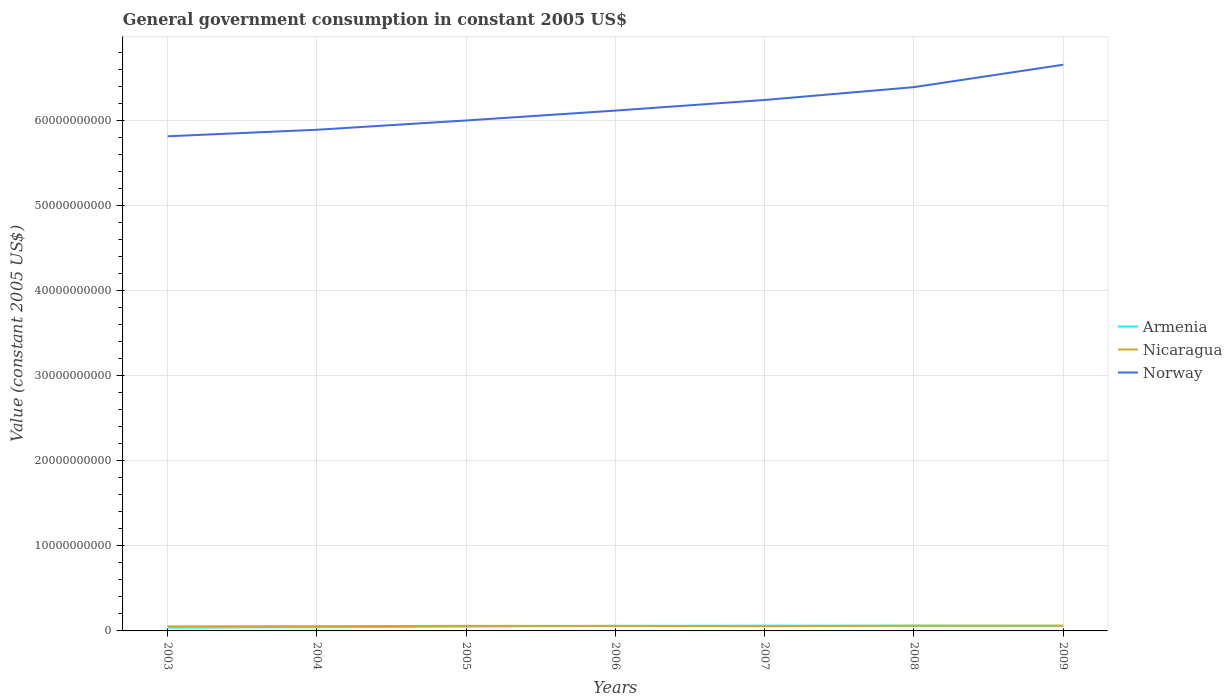How many different coloured lines are there?
Ensure brevity in your answer.  3. Does the line corresponding to Nicaragua intersect with the line corresponding to Armenia?
Provide a succinct answer. Yes. Is the number of lines equal to the number of legend labels?
Make the answer very short. Yes. Across all years, what is the maximum government conusmption in Armenia?
Offer a terse response. 3.91e+08. In which year was the government conusmption in Armenia maximum?
Provide a succinct answer. 2003. What is the total government conusmption in Nicaragua in the graph?
Ensure brevity in your answer.  -6.01e+07. What is the difference between the highest and the second highest government conusmption in Armenia?
Your response must be concise. 2.29e+08. What is the difference between the highest and the lowest government conusmption in Nicaragua?
Provide a short and direct response. 4. Are the values on the major ticks of Y-axis written in scientific E-notation?
Your answer should be very brief. No. Does the graph contain any zero values?
Keep it short and to the point. No. How many legend labels are there?
Offer a terse response. 3. What is the title of the graph?
Your answer should be compact. General government consumption in constant 2005 US$. Does "Bangladesh" appear as one of the legend labels in the graph?
Offer a very short reply. No. What is the label or title of the X-axis?
Provide a short and direct response. Years. What is the label or title of the Y-axis?
Your answer should be very brief. Value (constant 2005 US$). What is the Value (constant 2005 US$) in Armenia in 2003?
Offer a terse response. 3.91e+08. What is the Value (constant 2005 US$) in Nicaragua in 2003?
Give a very brief answer. 5.41e+08. What is the Value (constant 2005 US$) in Norway in 2003?
Provide a succinct answer. 5.82e+1. What is the Value (constant 2005 US$) in Armenia in 2004?
Your answer should be very brief. 4.34e+08. What is the Value (constant 2005 US$) of Nicaragua in 2004?
Give a very brief answer. 5.58e+08. What is the Value (constant 2005 US$) in Norway in 2004?
Provide a succinct answer. 5.89e+1. What is the Value (constant 2005 US$) in Armenia in 2005?
Ensure brevity in your answer.  5.17e+08. What is the Value (constant 2005 US$) in Nicaragua in 2005?
Ensure brevity in your answer.  5.96e+08. What is the Value (constant 2005 US$) in Norway in 2005?
Offer a terse response. 6.00e+1. What is the Value (constant 2005 US$) of Armenia in 2006?
Keep it short and to the point. 5.90e+08. What is the Value (constant 2005 US$) of Nicaragua in 2006?
Provide a succinct answer. 5.93e+08. What is the Value (constant 2005 US$) in Norway in 2006?
Provide a succinct answer. 6.12e+1. What is the Value (constant 2005 US$) in Armenia in 2007?
Provide a short and direct response. 6.20e+08. What is the Value (constant 2005 US$) in Nicaragua in 2007?
Your answer should be compact. 5.58e+08. What is the Value (constant 2005 US$) in Norway in 2007?
Your response must be concise. 6.24e+1. What is the Value (constant 2005 US$) of Armenia in 2008?
Your response must be concise. 6.09e+08. What is the Value (constant 2005 US$) of Nicaragua in 2008?
Give a very brief answer. 6.18e+08. What is the Value (constant 2005 US$) of Norway in 2008?
Ensure brevity in your answer.  6.39e+1. What is the Value (constant 2005 US$) of Armenia in 2009?
Your response must be concise. 6.01e+08. What is the Value (constant 2005 US$) in Nicaragua in 2009?
Give a very brief answer. 6.16e+08. What is the Value (constant 2005 US$) in Norway in 2009?
Your response must be concise. 6.66e+1. Across all years, what is the maximum Value (constant 2005 US$) in Armenia?
Make the answer very short. 6.20e+08. Across all years, what is the maximum Value (constant 2005 US$) of Nicaragua?
Provide a succinct answer. 6.18e+08. Across all years, what is the maximum Value (constant 2005 US$) of Norway?
Provide a succinct answer. 6.66e+1. Across all years, what is the minimum Value (constant 2005 US$) of Armenia?
Make the answer very short. 3.91e+08. Across all years, what is the minimum Value (constant 2005 US$) in Nicaragua?
Give a very brief answer. 5.41e+08. Across all years, what is the minimum Value (constant 2005 US$) in Norway?
Provide a succinct answer. 5.82e+1. What is the total Value (constant 2005 US$) in Armenia in the graph?
Ensure brevity in your answer.  3.76e+09. What is the total Value (constant 2005 US$) of Nicaragua in the graph?
Provide a short and direct response. 4.08e+09. What is the total Value (constant 2005 US$) in Norway in the graph?
Your answer should be very brief. 4.31e+11. What is the difference between the Value (constant 2005 US$) in Armenia in 2003 and that in 2004?
Make the answer very short. -4.30e+07. What is the difference between the Value (constant 2005 US$) in Nicaragua in 2003 and that in 2004?
Your answer should be compact. -1.71e+07. What is the difference between the Value (constant 2005 US$) of Norway in 2003 and that in 2004?
Keep it short and to the point. -7.66e+08. What is the difference between the Value (constant 2005 US$) of Armenia in 2003 and that in 2005?
Offer a terse response. -1.26e+08. What is the difference between the Value (constant 2005 US$) in Nicaragua in 2003 and that in 2005?
Ensure brevity in your answer.  -5.54e+07. What is the difference between the Value (constant 2005 US$) of Norway in 2003 and that in 2005?
Your answer should be compact. -1.86e+09. What is the difference between the Value (constant 2005 US$) of Armenia in 2003 and that in 2006?
Provide a short and direct response. -1.98e+08. What is the difference between the Value (constant 2005 US$) in Nicaragua in 2003 and that in 2006?
Provide a short and direct response. -5.22e+07. What is the difference between the Value (constant 2005 US$) of Norway in 2003 and that in 2006?
Your answer should be compact. -3.02e+09. What is the difference between the Value (constant 2005 US$) in Armenia in 2003 and that in 2007?
Offer a very short reply. -2.29e+08. What is the difference between the Value (constant 2005 US$) in Nicaragua in 2003 and that in 2007?
Your response must be concise. -1.73e+07. What is the difference between the Value (constant 2005 US$) of Norway in 2003 and that in 2007?
Your answer should be very brief. -4.27e+09. What is the difference between the Value (constant 2005 US$) in Armenia in 2003 and that in 2008?
Ensure brevity in your answer.  -2.17e+08. What is the difference between the Value (constant 2005 US$) in Nicaragua in 2003 and that in 2008?
Provide a succinct answer. -7.74e+07. What is the difference between the Value (constant 2005 US$) of Norway in 2003 and that in 2008?
Offer a very short reply. -5.78e+09. What is the difference between the Value (constant 2005 US$) in Armenia in 2003 and that in 2009?
Provide a short and direct response. -2.10e+08. What is the difference between the Value (constant 2005 US$) of Nicaragua in 2003 and that in 2009?
Make the answer very short. -7.58e+07. What is the difference between the Value (constant 2005 US$) of Norway in 2003 and that in 2009?
Give a very brief answer. -8.41e+09. What is the difference between the Value (constant 2005 US$) in Armenia in 2004 and that in 2005?
Give a very brief answer. -8.27e+07. What is the difference between the Value (constant 2005 US$) in Nicaragua in 2004 and that in 2005?
Provide a short and direct response. -3.83e+07. What is the difference between the Value (constant 2005 US$) of Norway in 2004 and that in 2005?
Offer a very short reply. -1.09e+09. What is the difference between the Value (constant 2005 US$) in Armenia in 2004 and that in 2006?
Your response must be concise. -1.55e+08. What is the difference between the Value (constant 2005 US$) of Nicaragua in 2004 and that in 2006?
Your answer should be very brief. -3.51e+07. What is the difference between the Value (constant 2005 US$) in Norway in 2004 and that in 2006?
Offer a very short reply. -2.25e+09. What is the difference between the Value (constant 2005 US$) in Armenia in 2004 and that in 2007?
Provide a short and direct response. -1.86e+08. What is the difference between the Value (constant 2005 US$) of Nicaragua in 2004 and that in 2007?
Your answer should be compact. -2.22e+05. What is the difference between the Value (constant 2005 US$) of Norway in 2004 and that in 2007?
Provide a succinct answer. -3.50e+09. What is the difference between the Value (constant 2005 US$) of Armenia in 2004 and that in 2008?
Make the answer very short. -1.74e+08. What is the difference between the Value (constant 2005 US$) in Nicaragua in 2004 and that in 2008?
Keep it short and to the point. -6.03e+07. What is the difference between the Value (constant 2005 US$) of Norway in 2004 and that in 2008?
Give a very brief answer. -5.01e+09. What is the difference between the Value (constant 2005 US$) of Armenia in 2004 and that in 2009?
Your response must be concise. -1.67e+08. What is the difference between the Value (constant 2005 US$) of Nicaragua in 2004 and that in 2009?
Keep it short and to the point. -5.87e+07. What is the difference between the Value (constant 2005 US$) of Norway in 2004 and that in 2009?
Give a very brief answer. -7.65e+09. What is the difference between the Value (constant 2005 US$) in Armenia in 2005 and that in 2006?
Ensure brevity in your answer.  -7.25e+07. What is the difference between the Value (constant 2005 US$) in Nicaragua in 2005 and that in 2006?
Give a very brief answer. 3.12e+06. What is the difference between the Value (constant 2005 US$) of Norway in 2005 and that in 2006?
Make the answer very short. -1.16e+09. What is the difference between the Value (constant 2005 US$) in Armenia in 2005 and that in 2007?
Make the answer very short. -1.03e+08. What is the difference between the Value (constant 2005 US$) in Nicaragua in 2005 and that in 2007?
Ensure brevity in your answer.  3.80e+07. What is the difference between the Value (constant 2005 US$) in Norway in 2005 and that in 2007?
Provide a short and direct response. -2.41e+09. What is the difference between the Value (constant 2005 US$) in Armenia in 2005 and that in 2008?
Your response must be concise. -9.18e+07. What is the difference between the Value (constant 2005 US$) of Nicaragua in 2005 and that in 2008?
Your answer should be very brief. -2.21e+07. What is the difference between the Value (constant 2005 US$) in Norway in 2005 and that in 2008?
Your answer should be very brief. -3.92e+09. What is the difference between the Value (constant 2005 US$) of Armenia in 2005 and that in 2009?
Your answer should be compact. -8.43e+07. What is the difference between the Value (constant 2005 US$) in Nicaragua in 2005 and that in 2009?
Offer a terse response. -2.04e+07. What is the difference between the Value (constant 2005 US$) of Norway in 2005 and that in 2009?
Provide a succinct answer. -6.56e+09. What is the difference between the Value (constant 2005 US$) of Armenia in 2006 and that in 2007?
Give a very brief answer. -3.08e+07. What is the difference between the Value (constant 2005 US$) in Nicaragua in 2006 and that in 2007?
Keep it short and to the point. 3.49e+07. What is the difference between the Value (constant 2005 US$) in Norway in 2006 and that in 2007?
Make the answer very short. -1.25e+09. What is the difference between the Value (constant 2005 US$) in Armenia in 2006 and that in 2008?
Offer a very short reply. -1.92e+07. What is the difference between the Value (constant 2005 US$) in Nicaragua in 2006 and that in 2008?
Your response must be concise. -2.52e+07. What is the difference between the Value (constant 2005 US$) of Norway in 2006 and that in 2008?
Give a very brief answer. -2.76e+09. What is the difference between the Value (constant 2005 US$) of Armenia in 2006 and that in 2009?
Ensure brevity in your answer.  -1.18e+07. What is the difference between the Value (constant 2005 US$) in Nicaragua in 2006 and that in 2009?
Make the answer very short. -2.36e+07. What is the difference between the Value (constant 2005 US$) in Norway in 2006 and that in 2009?
Offer a terse response. -5.39e+09. What is the difference between the Value (constant 2005 US$) in Armenia in 2007 and that in 2008?
Give a very brief answer. 1.15e+07. What is the difference between the Value (constant 2005 US$) in Nicaragua in 2007 and that in 2008?
Provide a succinct answer. -6.01e+07. What is the difference between the Value (constant 2005 US$) in Norway in 2007 and that in 2008?
Your answer should be compact. -1.51e+09. What is the difference between the Value (constant 2005 US$) in Armenia in 2007 and that in 2009?
Offer a very short reply. 1.90e+07. What is the difference between the Value (constant 2005 US$) of Nicaragua in 2007 and that in 2009?
Offer a very short reply. -5.85e+07. What is the difference between the Value (constant 2005 US$) in Norway in 2007 and that in 2009?
Your response must be concise. -4.15e+09. What is the difference between the Value (constant 2005 US$) in Armenia in 2008 and that in 2009?
Your answer should be compact. 7.45e+06. What is the difference between the Value (constant 2005 US$) in Nicaragua in 2008 and that in 2009?
Your answer should be very brief. 1.63e+06. What is the difference between the Value (constant 2005 US$) in Norway in 2008 and that in 2009?
Provide a short and direct response. -2.64e+09. What is the difference between the Value (constant 2005 US$) in Armenia in 2003 and the Value (constant 2005 US$) in Nicaragua in 2004?
Offer a very short reply. -1.66e+08. What is the difference between the Value (constant 2005 US$) in Armenia in 2003 and the Value (constant 2005 US$) in Norway in 2004?
Offer a very short reply. -5.85e+1. What is the difference between the Value (constant 2005 US$) in Nicaragua in 2003 and the Value (constant 2005 US$) in Norway in 2004?
Your answer should be very brief. -5.84e+1. What is the difference between the Value (constant 2005 US$) in Armenia in 2003 and the Value (constant 2005 US$) in Nicaragua in 2005?
Provide a succinct answer. -2.05e+08. What is the difference between the Value (constant 2005 US$) of Armenia in 2003 and the Value (constant 2005 US$) of Norway in 2005?
Your answer should be compact. -5.96e+1. What is the difference between the Value (constant 2005 US$) of Nicaragua in 2003 and the Value (constant 2005 US$) of Norway in 2005?
Your answer should be very brief. -5.95e+1. What is the difference between the Value (constant 2005 US$) of Armenia in 2003 and the Value (constant 2005 US$) of Nicaragua in 2006?
Provide a succinct answer. -2.02e+08. What is the difference between the Value (constant 2005 US$) of Armenia in 2003 and the Value (constant 2005 US$) of Norway in 2006?
Your response must be concise. -6.08e+1. What is the difference between the Value (constant 2005 US$) in Nicaragua in 2003 and the Value (constant 2005 US$) in Norway in 2006?
Your response must be concise. -6.06e+1. What is the difference between the Value (constant 2005 US$) of Armenia in 2003 and the Value (constant 2005 US$) of Nicaragua in 2007?
Ensure brevity in your answer.  -1.67e+08. What is the difference between the Value (constant 2005 US$) of Armenia in 2003 and the Value (constant 2005 US$) of Norway in 2007?
Your response must be concise. -6.20e+1. What is the difference between the Value (constant 2005 US$) in Nicaragua in 2003 and the Value (constant 2005 US$) in Norway in 2007?
Your answer should be compact. -6.19e+1. What is the difference between the Value (constant 2005 US$) of Armenia in 2003 and the Value (constant 2005 US$) of Nicaragua in 2008?
Your response must be concise. -2.27e+08. What is the difference between the Value (constant 2005 US$) of Armenia in 2003 and the Value (constant 2005 US$) of Norway in 2008?
Your answer should be very brief. -6.36e+1. What is the difference between the Value (constant 2005 US$) of Nicaragua in 2003 and the Value (constant 2005 US$) of Norway in 2008?
Provide a succinct answer. -6.34e+1. What is the difference between the Value (constant 2005 US$) of Armenia in 2003 and the Value (constant 2005 US$) of Nicaragua in 2009?
Your answer should be compact. -2.25e+08. What is the difference between the Value (constant 2005 US$) in Armenia in 2003 and the Value (constant 2005 US$) in Norway in 2009?
Give a very brief answer. -6.62e+1. What is the difference between the Value (constant 2005 US$) in Nicaragua in 2003 and the Value (constant 2005 US$) in Norway in 2009?
Your answer should be very brief. -6.60e+1. What is the difference between the Value (constant 2005 US$) of Armenia in 2004 and the Value (constant 2005 US$) of Nicaragua in 2005?
Offer a very short reply. -1.62e+08. What is the difference between the Value (constant 2005 US$) of Armenia in 2004 and the Value (constant 2005 US$) of Norway in 2005?
Ensure brevity in your answer.  -5.96e+1. What is the difference between the Value (constant 2005 US$) of Nicaragua in 2004 and the Value (constant 2005 US$) of Norway in 2005?
Your answer should be very brief. -5.95e+1. What is the difference between the Value (constant 2005 US$) of Armenia in 2004 and the Value (constant 2005 US$) of Nicaragua in 2006?
Offer a terse response. -1.59e+08. What is the difference between the Value (constant 2005 US$) of Armenia in 2004 and the Value (constant 2005 US$) of Norway in 2006?
Offer a terse response. -6.08e+1. What is the difference between the Value (constant 2005 US$) in Nicaragua in 2004 and the Value (constant 2005 US$) in Norway in 2006?
Offer a terse response. -6.06e+1. What is the difference between the Value (constant 2005 US$) of Armenia in 2004 and the Value (constant 2005 US$) of Nicaragua in 2007?
Make the answer very short. -1.24e+08. What is the difference between the Value (constant 2005 US$) of Armenia in 2004 and the Value (constant 2005 US$) of Norway in 2007?
Offer a terse response. -6.20e+1. What is the difference between the Value (constant 2005 US$) of Nicaragua in 2004 and the Value (constant 2005 US$) of Norway in 2007?
Your response must be concise. -6.19e+1. What is the difference between the Value (constant 2005 US$) of Armenia in 2004 and the Value (constant 2005 US$) of Nicaragua in 2008?
Your answer should be very brief. -1.84e+08. What is the difference between the Value (constant 2005 US$) of Armenia in 2004 and the Value (constant 2005 US$) of Norway in 2008?
Provide a short and direct response. -6.35e+1. What is the difference between the Value (constant 2005 US$) of Nicaragua in 2004 and the Value (constant 2005 US$) of Norway in 2008?
Provide a succinct answer. -6.34e+1. What is the difference between the Value (constant 2005 US$) of Armenia in 2004 and the Value (constant 2005 US$) of Nicaragua in 2009?
Provide a short and direct response. -1.82e+08. What is the difference between the Value (constant 2005 US$) of Armenia in 2004 and the Value (constant 2005 US$) of Norway in 2009?
Your answer should be compact. -6.62e+1. What is the difference between the Value (constant 2005 US$) in Nicaragua in 2004 and the Value (constant 2005 US$) in Norway in 2009?
Your answer should be compact. -6.60e+1. What is the difference between the Value (constant 2005 US$) in Armenia in 2005 and the Value (constant 2005 US$) in Nicaragua in 2006?
Offer a terse response. -7.58e+07. What is the difference between the Value (constant 2005 US$) of Armenia in 2005 and the Value (constant 2005 US$) of Norway in 2006?
Your response must be concise. -6.07e+1. What is the difference between the Value (constant 2005 US$) of Nicaragua in 2005 and the Value (constant 2005 US$) of Norway in 2006?
Ensure brevity in your answer.  -6.06e+1. What is the difference between the Value (constant 2005 US$) of Armenia in 2005 and the Value (constant 2005 US$) of Nicaragua in 2007?
Offer a terse response. -4.09e+07. What is the difference between the Value (constant 2005 US$) of Armenia in 2005 and the Value (constant 2005 US$) of Norway in 2007?
Give a very brief answer. -6.19e+1. What is the difference between the Value (constant 2005 US$) in Nicaragua in 2005 and the Value (constant 2005 US$) in Norway in 2007?
Your answer should be compact. -6.18e+1. What is the difference between the Value (constant 2005 US$) in Armenia in 2005 and the Value (constant 2005 US$) in Nicaragua in 2008?
Provide a short and direct response. -1.01e+08. What is the difference between the Value (constant 2005 US$) of Armenia in 2005 and the Value (constant 2005 US$) of Norway in 2008?
Your response must be concise. -6.34e+1. What is the difference between the Value (constant 2005 US$) of Nicaragua in 2005 and the Value (constant 2005 US$) of Norway in 2008?
Your answer should be compact. -6.34e+1. What is the difference between the Value (constant 2005 US$) of Armenia in 2005 and the Value (constant 2005 US$) of Nicaragua in 2009?
Provide a succinct answer. -9.94e+07. What is the difference between the Value (constant 2005 US$) in Armenia in 2005 and the Value (constant 2005 US$) in Norway in 2009?
Provide a short and direct response. -6.61e+1. What is the difference between the Value (constant 2005 US$) of Nicaragua in 2005 and the Value (constant 2005 US$) of Norway in 2009?
Make the answer very short. -6.60e+1. What is the difference between the Value (constant 2005 US$) in Armenia in 2006 and the Value (constant 2005 US$) in Nicaragua in 2007?
Provide a succinct answer. 3.16e+07. What is the difference between the Value (constant 2005 US$) in Armenia in 2006 and the Value (constant 2005 US$) in Norway in 2007?
Give a very brief answer. -6.18e+1. What is the difference between the Value (constant 2005 US$) in Nicaragua in 2006 and the Value (constant 2005 US$) in Norway in 2007?
Your response must be concise. -6.18e+1. What is the difference between the Value (constant 2005 US$) of Armenia in 2006 and the Value (constant 2005 US$) of Nicaragua in 2008?
Your answer should be very brief. -2.85e+07. What is the difference between the Value (constant 2005 US$) of Armenia in 2006 and the Value (constant 2005 US$) of Norway in 2008?
Your answer should be compact. -6.34e+1. What is the difference between the Value (constant 2005 US$) of Nicaragua in 2006 and the Value (constant 2005 US$) of Norway in 2008?
Your answer should be compact. -6.34e+1. What is the difference between the Value (constant 2005 US$) in Armenia in 2006 and the Value (constant 2005 US$) in Nicaragua in 2009?
Provide a short and direct response. -2.68e+07. What is the difference between the Value (constant 2005 US$) of Armenia in 2006 and the Value (constant 2005 US$) of Norway in 2009?
Make the answer very short. -6.60e+1. What is the difference between the Value (constant 2005 US$) in Nicaragua in 2006 and the Value (constant 2005 US$) in Norway in 2009?
Make the answer very short. -6.60e+1. What is the difference between the Value (constant 2005 US$) of Armenia in 2007 and the Value (constant 2005 US$) of Nicaragua in 2008?
Your answer should be very brief. 2.29e+06. What is the difference between the Value (constant 2005 US$) in Armenia in 2007 and the Value (constant 2005 US$) in Norway in 2008?
Offer a very short reply. -6.33e+1. What is the difference between the Value (constant 2005 US$) of Nicaragua in 2007 and the Value (constant 2005 US$) of Norway in 2008?
Your answer should be very brief. -6.34e+1. What is the difference between the Value (constant 2005 US$) of Armenia in 2007 and the Value (constant 2005 US$) of Nicaragua in 2009?
Your answer should be very brief. 3.92e+06. What is the difference between the Value (constant 2005 US$) in Armenia in 2007 and the Value (constant 2005 US$) in Norway in 2009?
Offer a terse response. -6.60e+1. What is the difference between the Value (constant 2005 US$) of Nicaragua in 2007 and the Value (constant 2005 US$) of Norway in 2009?
Provide a succinct answer. -6.60e+1. What is the difference between the Value (constant 2005 US$) in Armenia in 2008 and the Value (constant 2005 US$) in Nicaragua in 2009?
Offer a terse response. -7.62e+06. What is the difference between the Value (constant 2005 US$) in Armenia in 2008 and the Value (constant 2005 US$) in Norway in 2009?
Provide a short and direct response. -6.60e+1. What is the difference between the Value (constant 2005 US$) of Nicaragua in 2008 and the Value (constant 2005 US$) of Norway in 2009?
Your answer should be very brief. -6.60e+1. What is the average Value (constant 2005 US$) of Armenia per year?
Your response must be concise. 5.38e+08. What is the average Value (constant 2005 US$) in Nicaragua per year?
Keep it short and to the point. 5.83e+08. What is the average Value (constant 2005 US$) in Norway per year?
Provide a short and direct response. 6.16e+1. In the year 2003, what is the difference between the Value (constant 2005 US$) in Armenia and Value (constant 2005 US$) in Nicaragua?
Provide a succinct answer. -1.49e+08. In the year 2003, what is the difference between the Value (constant 2005 US$) of Armenia and Value (constant 2005 US$) of Norway?
Provide a short and direct response. -5.78e+1. In the year 2003, what is the difference between the Value (constant 2005 US$) in Nicaragua and Value (constant 2005 US$) in Norway?
Ensure brevity in your answer.  -5.76e+1. In the year 2004, what is the difference between the Value (constant 2005 US$) in Armenia and Value (constant 2005 US$) in Nicaragua?
Keep it short and to the point. -1.23e+08. In the year 2004, what is the difference between the Value (constant 2005 US$) in Armenia and Value (constant 2005 US$) in Norway?
Provide a short and direct response. -5.85e+1. In the year 2004, what is the difference between the Value (constant 2005 US$) of Nicaragua and Value (constant 2005 US$) of Norway?
Make the answer very short. -5.84e+1. In the year 2005, what is the difference between the Value (constant 2005 US$) in Armenia and Value (constant 2005 US$) in Nicaragua?
Your answer should be compact. -7.89e+07. In the year 2005, what is the difference between the Value (constant 2005 US$) in Armenia and Value (constant 2005 US$) in Norway?
Give a very brief answer. -5.95e+1. In the year 2005, what is the difference between the Value (constant 2005 US$) of Nicaragua and Value (constant 2005 US$) of Norway?
Provide a short and direct response. -5.94e+1. In the year 2006, what is the difference between the Value (constant 2005 US$) in Armenia and Value (constant 2005 US$) in Nicaragua?
Your answer should be compact. -3.30e+06. In the year 2006, what is the difference between the Value (constant 2005 US$) in Armenia and Value (constant 2005 US$) in Norway?
Your answer should be very brief. -6.06e+1. In the year 2006, what is the difference between the Value (constant 2005 US$) in Nicaragua and Value (constant 2005 US$) in Norway?
Your answer should be compact. -6.06e+1. In the year 2007, what is the difference between the Value (constant 2005 US$) in Armenia and Value (constant 2005 US$) in Nicaragua?
Keep it short and to the point. 6.24e+07. In the year 2007, what is the difference between the Value (constant 2005 US$) of Armenia and Value (constant 2005 US$) of Norway?
Offer a very short reply. -6.18e+1. In the year 2007, what is the difference between the Value (constant 2005 US$) in Nicaragua and Value (constant 2005 US$) in Norway?
Your answer should be compact. -6.19e+1. In the year 2008, what is the difference between the Value (constant 2005 US$) of Armenia and Value (constant 2005 US$) of Nicaragua?
Your answer should be compact. -9.25e+06. In the year 2008, what is the difference between the Value (constant 2005 US$) in Armenia and Value (constant 2005 US$) in Norway?
Offer a terse response. -6.33e+1. In the year 2008, what is the difference between the Value (constant 2005 US$) of Nicaragua and Value (constant 2005 US$) of Norway?
Give a very brief answer. -6.33e+1. In the year 2009, what is the difference between the Value (constant 2005 US$) in Armenia and Value (constant 2005 US$) in Nicaragua?
Ensure brevity in your answer.  -1.51e+07. In the year 2009, what is the difference between the Value (constant 2005 US$) of Armenia and Value (constant 2005 US$) of Norway?
Ensure brevity in your answer.  -6.60e+1. In the year 2009, what is the difference between the Value (constant 2005 US$) in Nicaragua and Value (constant 2005 US$) in Norway?
Your answer should be very brief. -6.60e+1. What is the ratio of the Value (constant 2005 US$) in Armenia in 2003 to that in 2004?
Offer a very short reply. 0.9. What is the ratio of the Value (constant 2005 US$) of Nicaragua in 2003 to that in 2004?
Make the answer very short. 0.97. What is the ratio of the Value (constant 2005 US$) of Norway in 2003 to that in 2004?
Offer a very short reply. 0.99. What is the ratio of the Value (constant 2005 US$) of Armenia in 2003 to that in 2005?
Make the answer very short. 0.76. What is the ratio of the Value (constant 2005 US$) in Nicaragua in 2003 to that in 2005?
Offer a terse response. 0.91. What is the ratio of the Value (constant 2005 US$) in Norway in 2003 to that in 2005?
Your response must be concise. 0.97. What is the ratio of the Value (constant 2005 US$) in Armenia in 2003 to that in 2006?
Offer a terse response. 0.66. What is the ratio of the Value (constant 2005 US$) in Nicaragua in 2003 to that in 2006?
Your answer should be compact. 0.91. What is the ratio of the Value (constant 2005 US$) of Norway in 2003 to that in 2006?
Provide a succinct answer. 0.95. What is the ratio of the Value (constant 2005 US$) of Armenia in 2003 to that in 2007?
Your response must be concise. 0.63. What is the ratio of the Value (constant 2005 US$) of Nicaragua in 2003 to that in 2007?
Give a very brief answer. 0.97. What is the ratio of the Value (constant 2005 US$) of Norway in 2003 to that in 2007?
Provide a short and direct response. 0.93. What is the ratio of the Value (constant 2005 US$) in Armenia in 2003 to that in 2008?
Your answer should be very brief. 0.64. What is the ratio of the Value (constant 2005 US$) in Nicaragua in 2003 to that in 2008?
Your answer should be very brief. 0.87. What is the ratio of the Value (constant 2005 US$) in Norway in 2003 to that in 2008?
Provide a short and direct response. 0.91. What is the ratio of the Value (constant 2005 US$) in Armenia in 2003 to that in 2009?
Provide a succinct answer. 0.65. What is the ratio of the Value (constant 2005 US$) of Nicaragua in 2003 to that in 2009?
Ensure brevity in your answer.  0.88. What is the ratio of the Value (constant 2005 US$) of Norway in 2003 to that in 2009?
Offer a very short reply. 0.87. What is the ratio of the Value (constant 2005 US$) in Armenia in 2004 to that in 2005?
Ensure brevity in your answer.  0.84. What is the ratio of the Value (constant 2005 US$) in Nicaragua in 2004 to that in 2005?
Keep it short and to the point. 0.94. What is the ratio of the Value (constant 2005 US$) in Norway in 2004 to that in 2005?
Provide a short and direct response. 0.98. What is the ratio of the Value (constant 2005 US$) in Armenia in 2004 to that in 2006?
Give a very brief answer. 0.74. What is the ratio of the Value (constant 2005 US$) in Nicaragua in 2004 to that in 2006?
Provide a succinct answer. 0.94. What is the ratio of the Value (constant 2005 US$) in Norway in 2004 to that in 2006?
Provide a succinct answer. 0.96. What is the ratio of the Value (constant 2005 US$) in Armenia in 2004 to that in 2007?
Provide a short and direct response. 0.7. What is the ratio of the Value (constant 2005 US$) of Norway in 2004 to that in 2007?
Your response must be concise. 0.94. What is the ratio of the Value (constant 2005 US$) in Armenia in 2004 to that in 2008?
Provide a short and direct response. 0.71. What is the ratio of the Value (constant 2005 US$) of Nicaragua in 2004 to that in 2008?
Offer a terse response. 0.9. What is the ratio of the Value (constant 2005 US$) in Norway in 2004 to that in 2008?
Offer a terse response. 0.92. What is the ratio of the Value (constant 2005 US$) in Armenia in 2004 to that in 2009?
Provide a short and direct response. 0.72. What is the ratio of the Value (constant 2005 US$) of Nicaragua in 2004 to that in 2009?
Your answer should be very brief. 0.9. What is the ratio of the Value (constant 2005 US$) of Norway in 2004 to that in 2009?
Make the answer very short. 0.89. What is the ratio of the Value (constant 2005 US$) of Armenia in 2005 to that in 2006?
Give a very brief answer. 0.88. What is the ratio of the Value (constant 2005 US$) in Nicaragua in 2005 to that in 2006?
Your answer should be compact. 1.01. What is the ratio of the Value (constant 2005 US$) of Norway in 2005 to that in 2006?
Provide a short and direct response. 0.98. What is the ratio of the Value (constant 2005 US$) of Armenia in 2005 to that in 2007?
Ensure brevity in your answer.  0.83. What is the ratio of the Value (constant 2005 US$) of Nicaragua in 2005 to that in 2007?
Your answer should be very brief. 1.07. What is the ratio of the Value (constant 2005 US$) of Norway in 2005 to that in 2007?
Offer a terse response. 0.96. What is the ratio of the Value (constant 2005 US$) in Armenia in 2005 to that in 2008?
Your answer should be compact. 0.85. What is the ratio of the Value (constant 2005 US$) of Nicaragua in 2005 to that in 2008?
Keep it short and to the point. 0.96. What is the ratio of the Value (constant 2005 US$) in Norway in 2005 to that in 2008?
Make the answer very short. 0.94. What is the ratio of the Value (constant 2005 US$) in Armenia in 2005 to that in 2009?
Your answer should be very brief. 0.86. What is the ratio of the Value (constant 2005 US$) of Nicaragua in 2005 to that in 2009?
Offer a very short reply. 0.97. What is the ratio of the Value (constant 2005 US$) of Norway in 2005 to that in 2009?
Provide a succinct answer. 0.9. What is the ratio of the Value (constant 2005 US$) of Armenia in 2006 to that in 2007?
Offer a very short reply. 0.95. What is the ratio of the Value (constant 2005 US$) in Nicaragua in 2006 to that in 2007?
Provide a succinct answer. 1.06. What is the ratio of the Value (constant 2005 US$) of Norway in 2006 to that in 2007?
Ensure brevity in your answer.  0.98. What is the ratio of the Value (constant 2005 US$) in Armenia in 2006 to that in 2008?
Ensure brevity in your answer.  0.97. What is the ratio of the Value (constant 2005 US$) in Nicaragua in 2006 to that in 2008?
Your response must be concise. 0.96. What is the ratio of the Value (constant 2005 US$) in Norway in 2006 to that in 2008?
Your response must be concise. 0.96. What is the ratio of the Value (constant 2005 US$) of Armenia in 2006 to that in 2009?
Give a very brief answer. 0.98. What is the ratio of the Value (constant 2005 US$) in Nicaragua in 2006 to that in 2009?
Your answer should be very brief. 0.96. What is the ratio of the Value (constant 2005 US$) in Norway in 2006 to that in 2009?
Ensure brevity in your answer.  0.92. What is the ratio of the Value (constant 2005 US$) in Armenia in 2007 to that in 2008?
Provide a succinct answer. 1.02. What is the ratio of the Value (constant 2005 US$) in Nicaragua in 2007 to that in 2008?
Provide a succinct answer. 0.9. What is the ratio of the Value (constant 2005 US$) of Norway in 2007 to that in 2008?
Offer a terse response. 0.98. What is the ratio of the Value (constant 2005 US$) in Armenia in 2007 to that in 2009?
Give a very brief answer. 1.03. What is the ratio of the Value (constant 2005 US$) of Nicaragua in 2007 to that in 2009?
Ensure brevity in your answer.  0.91. What is the ratio of the Value (constant 2005 US$) in Norway in 2007 to that in 2009?
Your response must be concise. 0.94. What is the ratio of the Value (constant 2005 US$) in Armenia in 2008 to that in 2009?
Keep it short and to the point. 1.01. What is the ratio of the Value (constant 2005 US$) of Norway in 2008 to that in 2009?
Your answer should be very brief. 0.96. What is the difference between the highest and the second highest Value (constant 2005 US$) of Armenia?
Ensure brevity in your answer.  1.15e+07. What is the difference between the highest and the second highest Value (constant 2005 US$) of Nicaragua?
Your response must be concise. 1.63e+06. What is the difference between the highest and the second highest Value (constant 2005 US$) in Norway?
Provide a succinct answer. 2.64e+09. What is the difference between the highest and the lowest Value (constant 2005 US$) of Armenia?
Give a very brief answer. 2.29e+08. What is the difference between the highest and the lowest Value (constant 2005 US$) of Nicaragua?
Provide a succinct answer. 7.74e+07. What is the difference between the highest and the lowest Value (constant 2005 US$) of Norway?
Your response must be concise. 8.41e+09. 